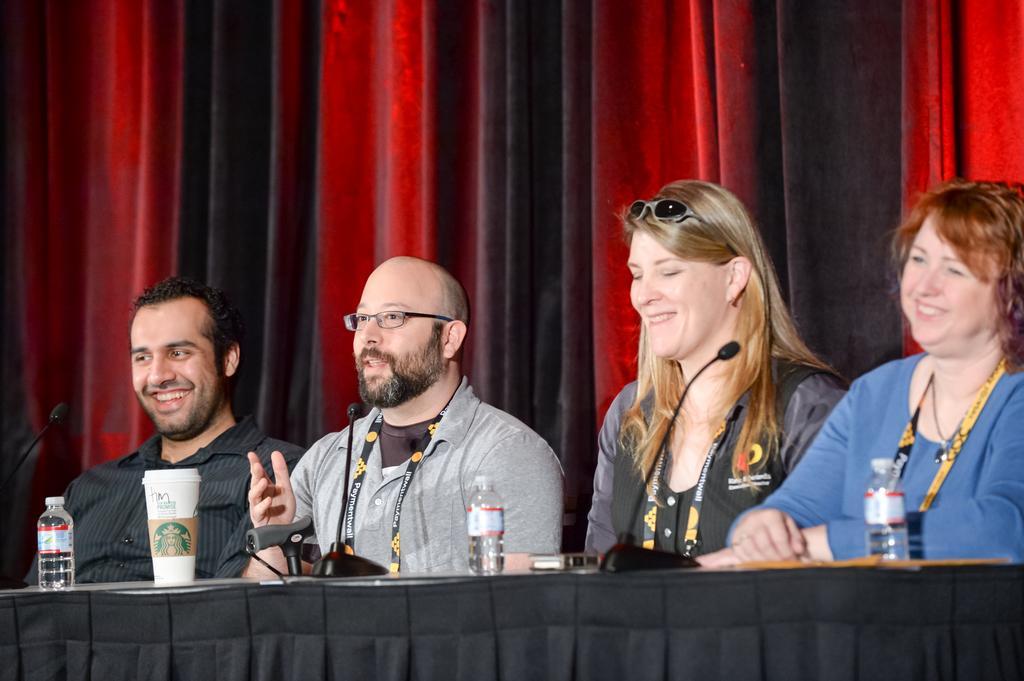Could you give a brief overview of what you see in this image? The picture is taken in a conference. In the center of the picture there are two men and two women sitting, in front of them there is a desk, on the desk there are mice, water bottles and a cup. In the background there is a black and red curtain. 